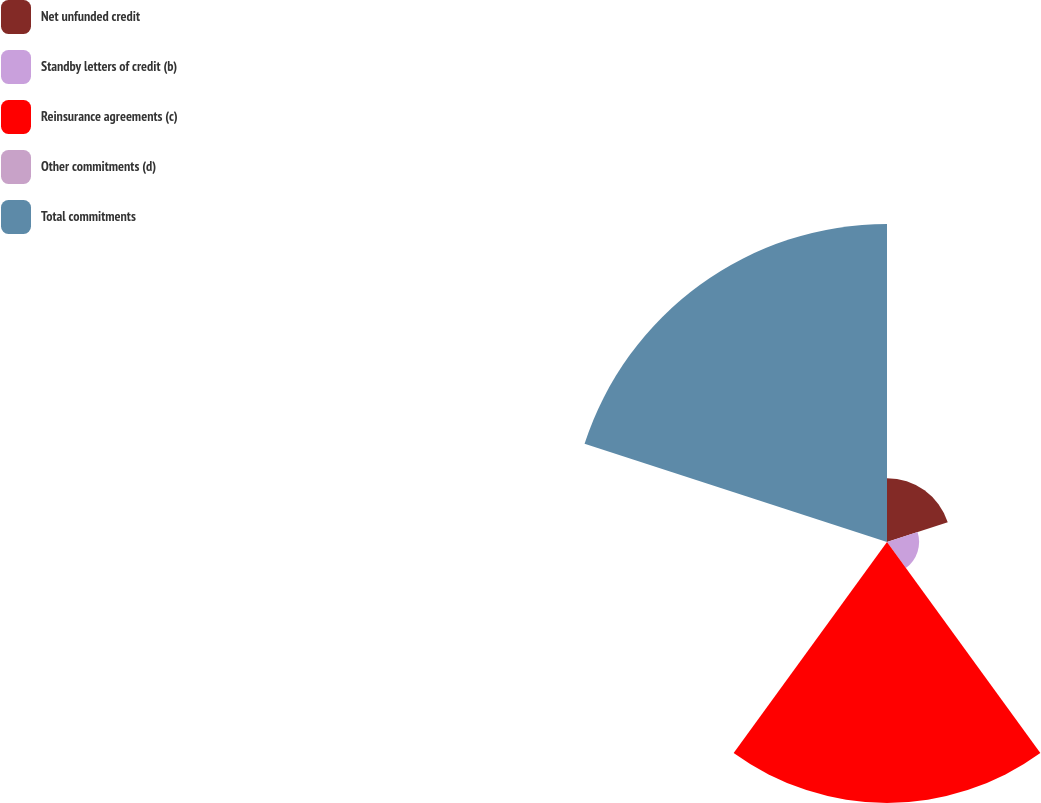<chart> <loc_0><loc_0><loc_500><loc_500><pie_chart><fcel>Net unfunded credit<fcel>Standby letters of credit (b)<fcel>Reinsurance agreements (c)<fcel>Other commitments (d)<fcel>Total commitments<nl><fcel>9.46%<fcel>4.75%<fcel>38.64%<fcel>0.05%<fcel>47.1%<nl></chart> 